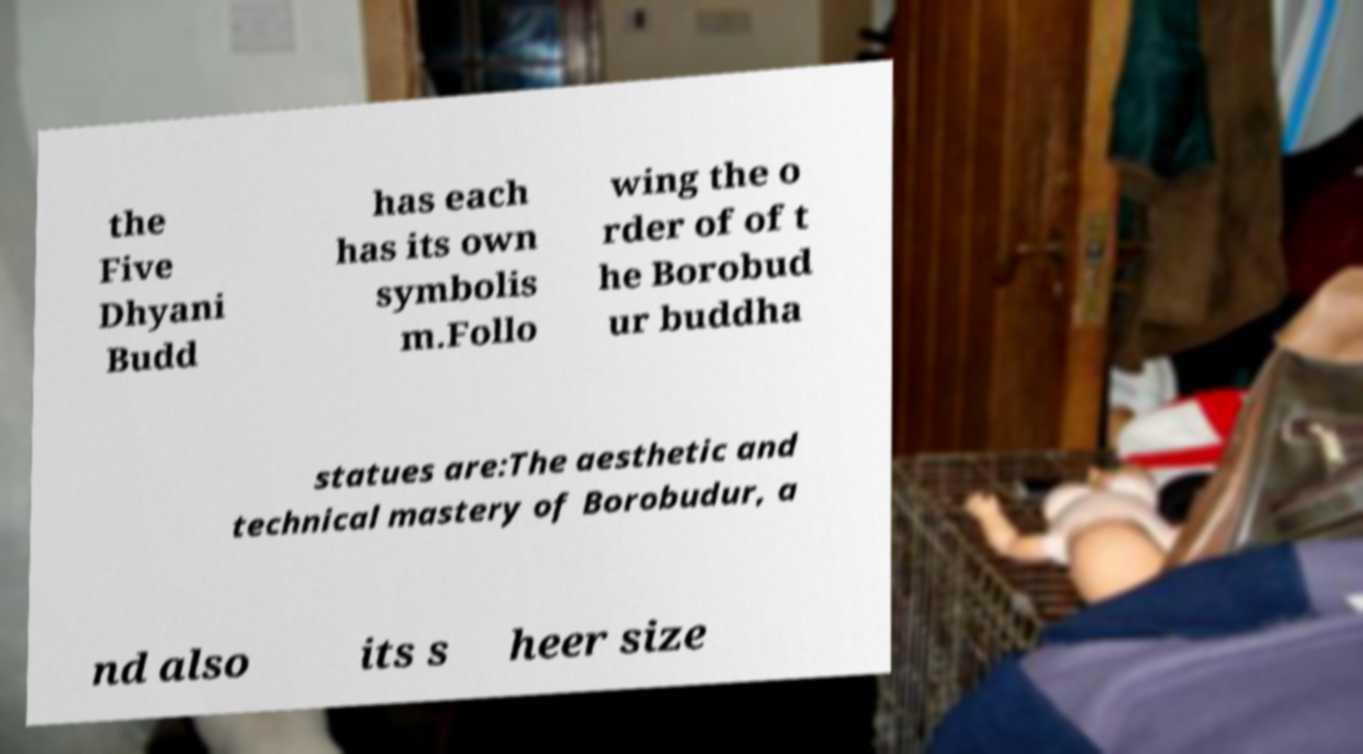There's text embedded in this image that I need extracted. Can you transcribe it verbatim? the Five Dhyani Budd has each has its own symbolis m.Follo wing the o rder of of t he Borobud ur buddha statues are:The aesthetic and technical mastery of Borobudur, a nd also its s heer size 